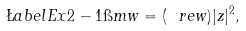Convert formula to latex. <formula><loc_0><loc_0><loc_500><loc_500>\L a b e l { E x 2 - 1 } \i m w = ( \ r e w ) | z | ^ { 2 } ,</formula> 